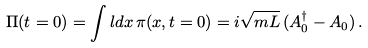<formula> <loc_0><loc_0><loc_500><loc_500>\Pi ( t = 0 ) = \int l d x \, \pi ( x , t = 0 ) = i \sqrt { m L } \, ( A _ { 0 } ^ { \dagger } - A _ { 0 } ) \, .</formula> 